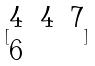<formula> <loc_0><loc_0><loc_500><loc_500>[ \begin{matrix} 4 & 4 & 7 \\ 6 \end{matrix} ]</formula> 